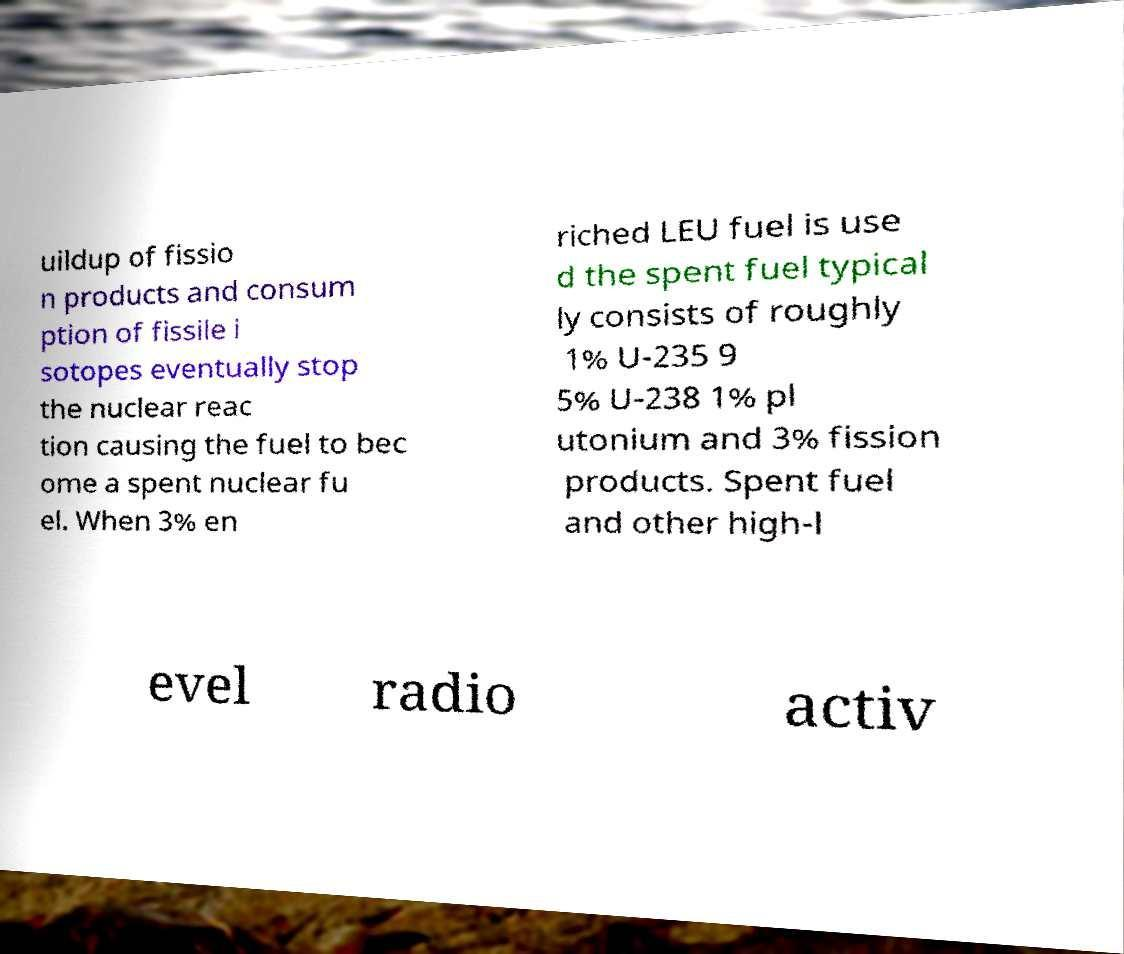I need the written content from this picture converted into text. Can you do that? uildup of fissio n products and consum ption of fissile i sotopes eventually stop the nuclear reac tion causing the fuel to bec ome a spent nuclear fu el. When 3% en riched LEU fuel is use d the spent fuel typical ly consists of roughly 1% U-235 9 5% U-238 1% pl utonium and 3% fission products. Spent fuel and other high-l evel radio activ 